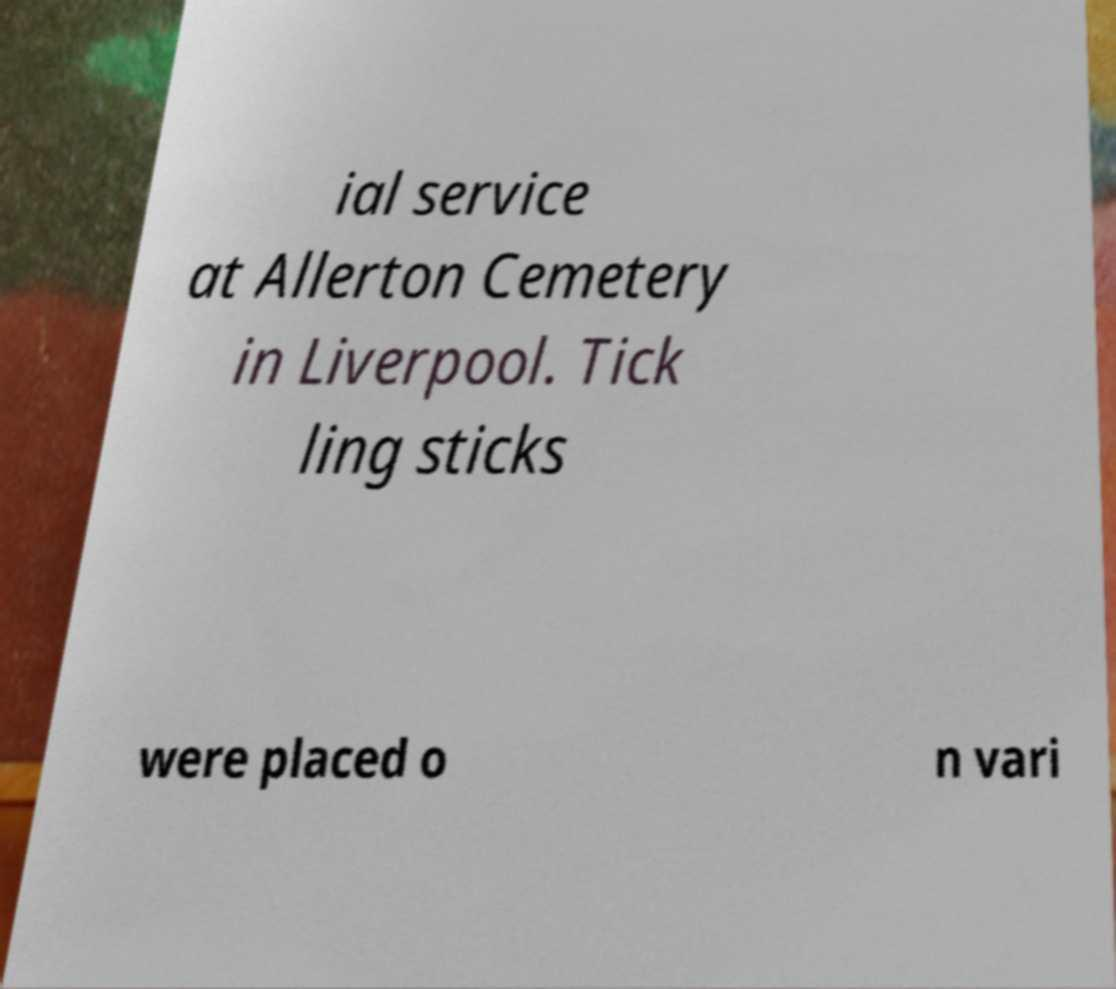I need the written content from this picture converted into text. Can you do that? ial service at Allerton Cemetery in Liverpool. Tick ling sticks were placed o n vari 